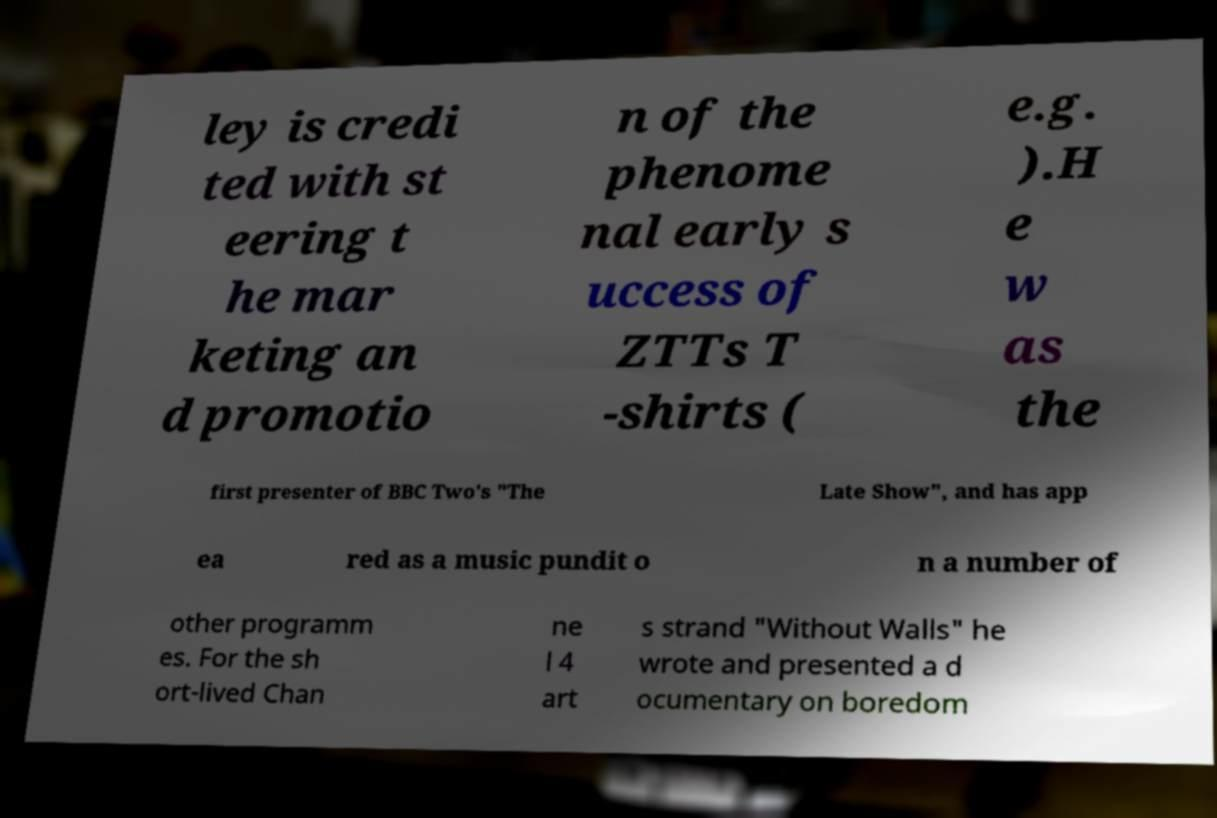Please read and relay the text visible in this image. What does it say? ley is credi ted with st eering t he mar keting an d promotio n of the phenome nal early s uccess of ZTTs T -shirts ( e.g. ).H e w as the first presenter of BBC Two's "The Late Show", and has app ea red as a music pundit o n a number of other programm es. For the sh ort-lived Chan ne l 4 art s strand "Without Walls" he wrote and presented a d ocumentary on boredom 